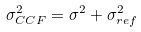Convert formula to latex. <formula><loc_0><loc_0><loc_500><loc_500>\sigma _ { C C F } ^ { 2 } = \sigma ^ { 2 } + \sigma _ { r e f } ^ { 2 }</formula> 